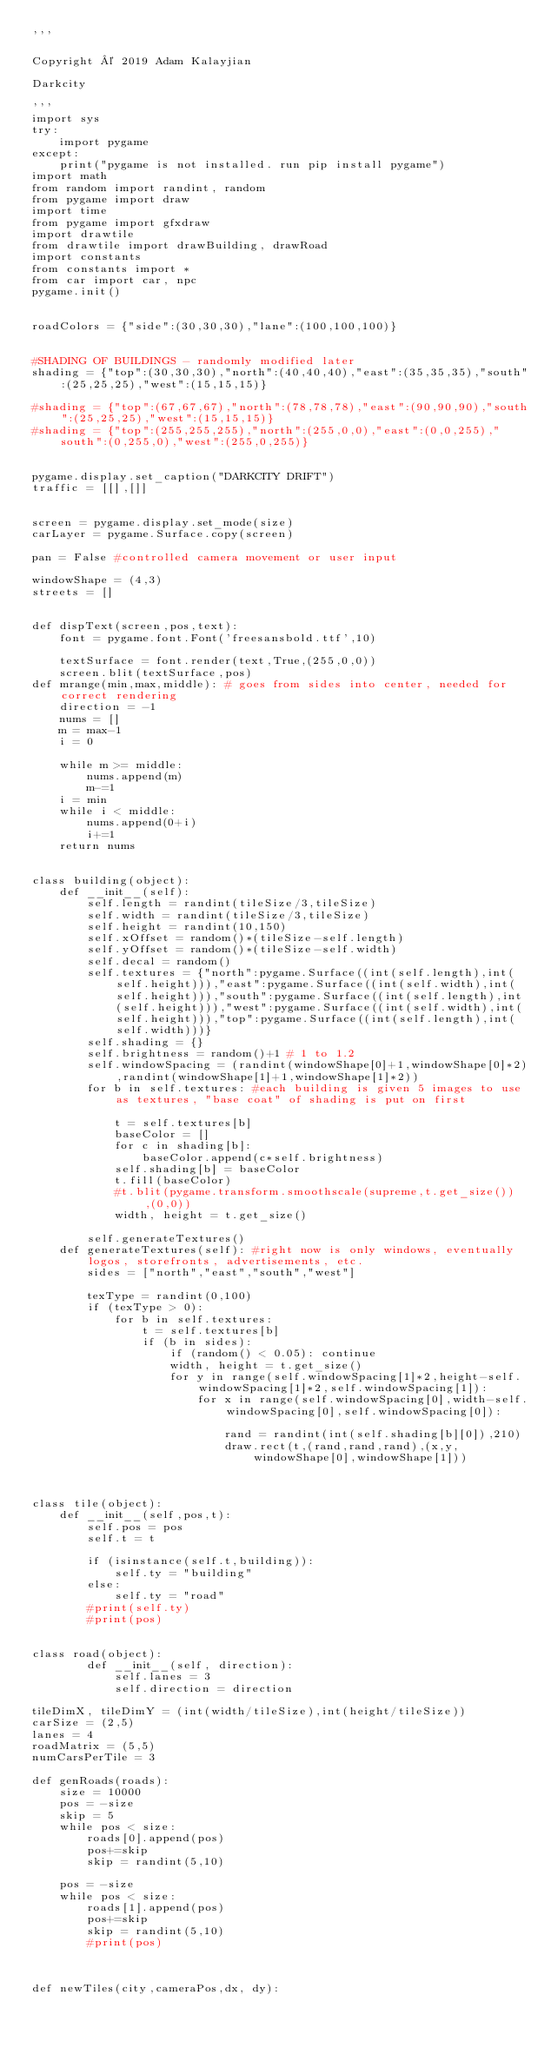Convert code to text. <code><loc_0><loc_0><loc_500><loc_500><_Python_>'''

Copyright © 2019 Adam Kalayjian

Darkcity

'''
import sys
try:
	import pygame
except:
	print("pygame is not installed. run pip install pygame")
import math
from random import randint, random
from pygame import draw
import time
from pygame import gfxdraw
import drawtile
from drawtile import drawBuilding, drawRoad 
import constants
from constants import *
from car import car, npc
pygame.init()


roadColors = {"side":(30,30,30),"lane":(100,100,100)}


#SHADING OF BUILDINGS - randomly modified later
shading = {"top":(30,30,30),"north":(40,40,40),"east":(35,35,35),"south":(25,25,25),"west":(15,15,15)}

#shading = {"top":(67,67,67),"north":(78,78,78),"east":(90,90,90),"south":(25,25,25),"west":(15,15,15)}
#shading = {"top":(255,255,255),"north":(255,0,0),"east":(0,0,255),"south":(0,255,0),"west":(255,0,255)}


pygame.display.set_caption("DARKCITY DRIFT")
traffic = [[],[]]


screen = pygame.display.set_mode(size)
carLayer = pygame.Surface.copy(screen)

pan = False #controlled camera movement or user input

windowShape = (4,3)
streets = []


def dispText(screen,pos,text):
	font = pygame.font.Font('freesansbold.ttf',10)

	textSurface = font.render(text,True,(255,0,0))
	screen.blit(textSurface,pos)
def mrange(min,max,middle): # goes from sides into center, needed for correct rendering
    direction = -1
    nums = []
    m = max-1
    i = 0

    while m >= middle:        
        nums.append(m)
        m-=1
    i = min
    while i < middle:        
        nums.append(0+i)
        i+=1
    return nums


class building(object):  
	def __init__(self):
		self.length = randint(tileSize/3,tileSize)
		self.width = randint(tileSize/3,tileSize)
		self.height = randint(10,150)
		self.xOffset = random()*(tileSize-self.length)
		self.yOffset = random()*(tileSize-self.width)
		self.decal = random()
		self.textures = {"north":pygame.Surface((int(self.length),int(self.height))),"east":pygame.Surface((int(self.width),int(self.height))),"south":pygame.Surface((int(self.length),int(self.height))),"west":pygame.Surface((int(self.width),int(self.height))),"top":pygame.Surface((int(self.length),int(self.width)))}
		self.shading = {}
		self.brightness = random()+1 # 1 to 1.2
		self.windowSpacing = (randint(windowShape[0]+1,windowShape[0]*2),randint(windowShape[1]+1,windowShape[1]*2))
		for b in self.textures: #each building is given 5 images to use as textures, "base coat" of shading is put on first

			t = self.textures[b]
			baseColor = []
			for c in shading[b]:
				baseColor.append(c*self.brightness)
			self.shading[b] = baseColor
			t.fill(baseColor)
			#t.blit(pygame.transform.smoothscale(supreme,t.get_size()),(0,0))
			width, height = t.get_size()

		self.generateTextures()
	def generateTextures(self): #right now is only windows, eventually logos, storefronts, advertisements, etc.
		sides = ["north","east","south","west"]

		texType = randint(0,100)
		if (texType > 0):
			for b in self.textures:
				t = self.textures[b]
				if (b in sides):
					if (random() < 0.05): continue
					width, height = t.get_size()
					for y in range(self.windowSpacing[1]*2,height-self.windowSpacing[1]*2,self.windowSpacing[1]):
						for x in range(self.windowSpacing[0],width-self.windowSpacing[0],self.windowSpacing[0]):
							
							rand = randint(int(self.shading[b][0]),210)
							draw.rect(t,(rand,rand,rand),(x,y,windowShape[0],windowShape[1]))



class tile(object):
	def __init__(self,pos,t):
		self.pos = pos
		self.t = t

		if (isinstance(self.t,building)):
			self.ty = "building"
		else:
			self.ty = "road"
		#print(self.ty)
		#print(pos)
		

class road(object):		
		def __init__(self, direction):
			self.lanes = 3
			self.direction = direction
			
tileDimX, tileDimY = (int(width/tileSize),int(height/tileSize))
carSize = (2,5)		
lanes = 4
roadMatrix = (5,5)
numCarsPerTile = 3

def genRoads(roads):
	size = 10000
	pos = -size
	skip = 5
	while pos < size:
		roads[0].append(pos)
		pos+=skip
		skip = randint(5,10)
		
	pos = -size
	while pos < size:
		roads[1].append(pos)
		pos+=skip
		skip = randint(5,10)
		#print(pos)
	
		

def newTiles(city,cameraPos,dx, dy):</code> 